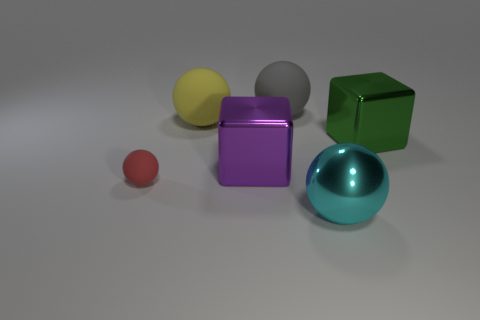Subtract 1 balls. How many balls are left? 3 Subtract all large spheres. How many spheres are left? 1 Subtract all red spheres. How many spheres are left? 3 Add 3 purple shiny blocks. How many objects exist? 9 Subtract all blocks. How many objects are left? 4 Subtract all small blue objects. Subtract all big green metallic things. How many objects are left? 5 Add 1 large gray rubber balls. How many large gray rubber balls are left? 2 Add 5 cyan objects. How many cyan objects exist? 6 Subtract 1 yellow spheres. How many objects are left? 5 